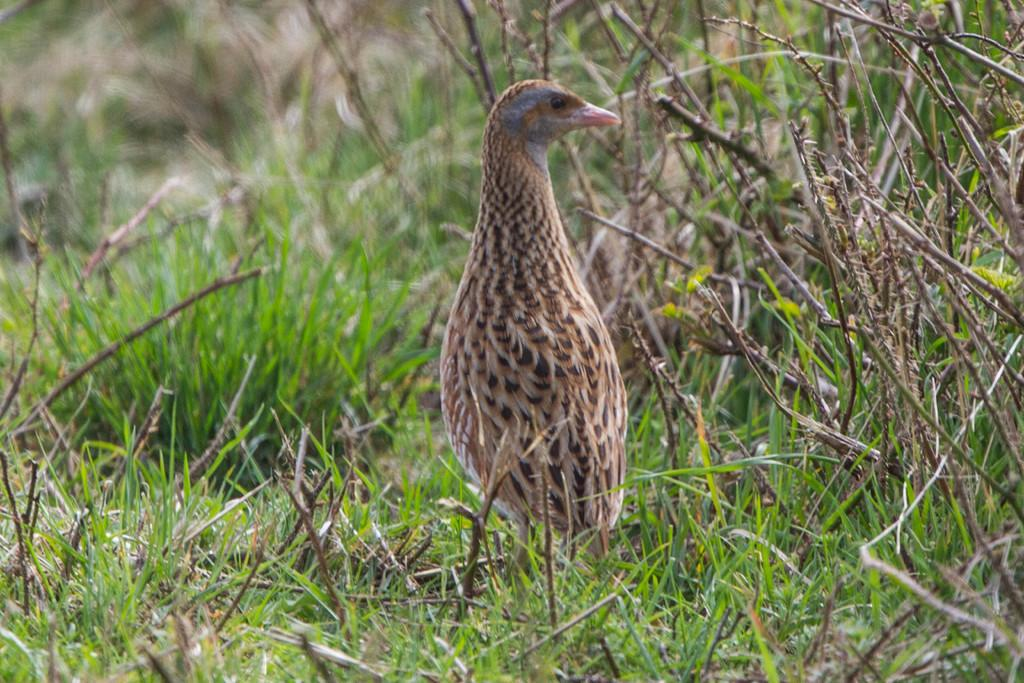What type of animal is in the image? There is a bird in the image. Can you describe the colors of the bird? The bird has cream, grey, and brown colors. What type of vegetation is present in the image? There is grass in the image. What else can be seen in the image besides the bird and grass? There are stems in the image. What type of pizzas is the queen eating in the image? There is no queen or pizzas present in the image; it features a bird and vegetation. 